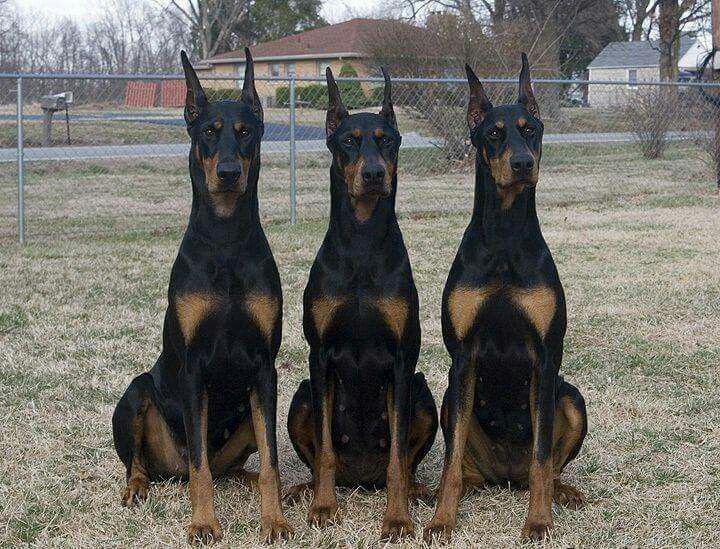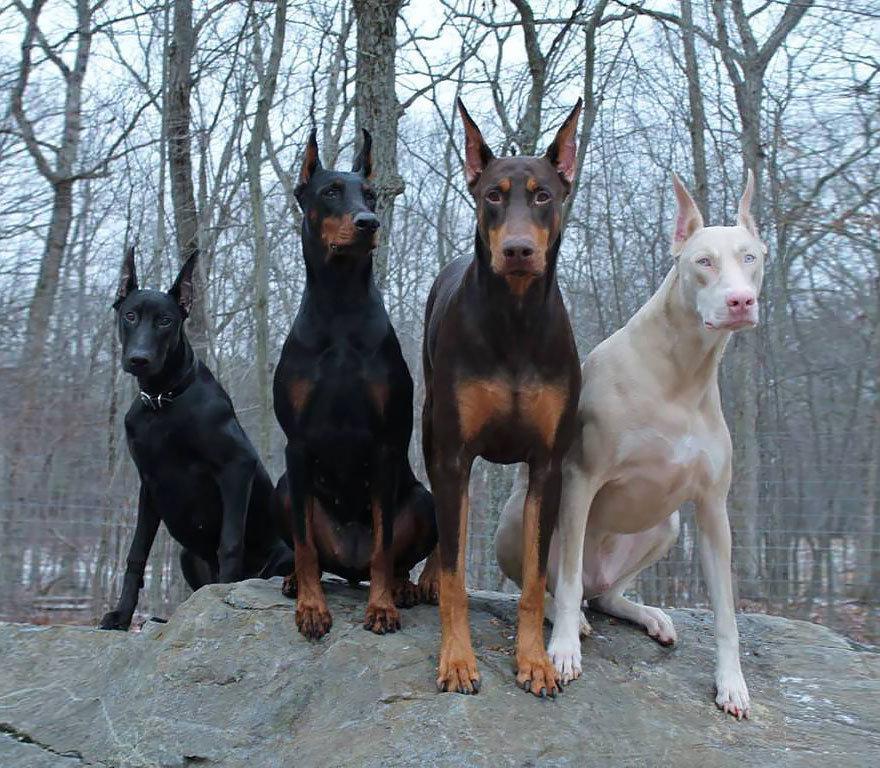The first image is the image on the left, the second image is the image on the right. For the images displayed, is the sentence "There are more dogs in the image on the right" factually correct? Answer yes or no. Yes. The first image is the image on the left, the second image is the image on the right. Examine the images to the left and right. Is the description "There are at least five dogs." accurate? Answer yes or no. Yes. 